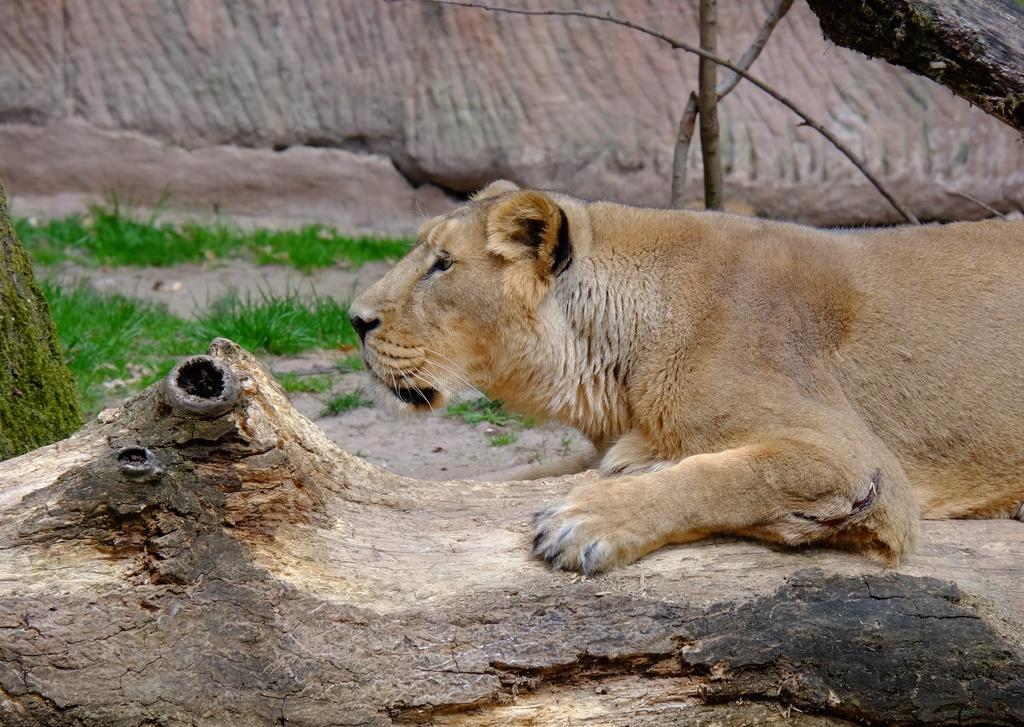What animal is in the image? There is a tiger in the image. What is the tiger standing on? The tiger is on a wooden bark. What type of vegetation can be seen in the image? There is grass visible in the image. What type of string is being used to hold the pear in the image? There is no string or pear present in the image. Where is the tiger located in the hall in the image? The image does not mention a hall, and the tiger's location is already described as being on a wooden bark. 